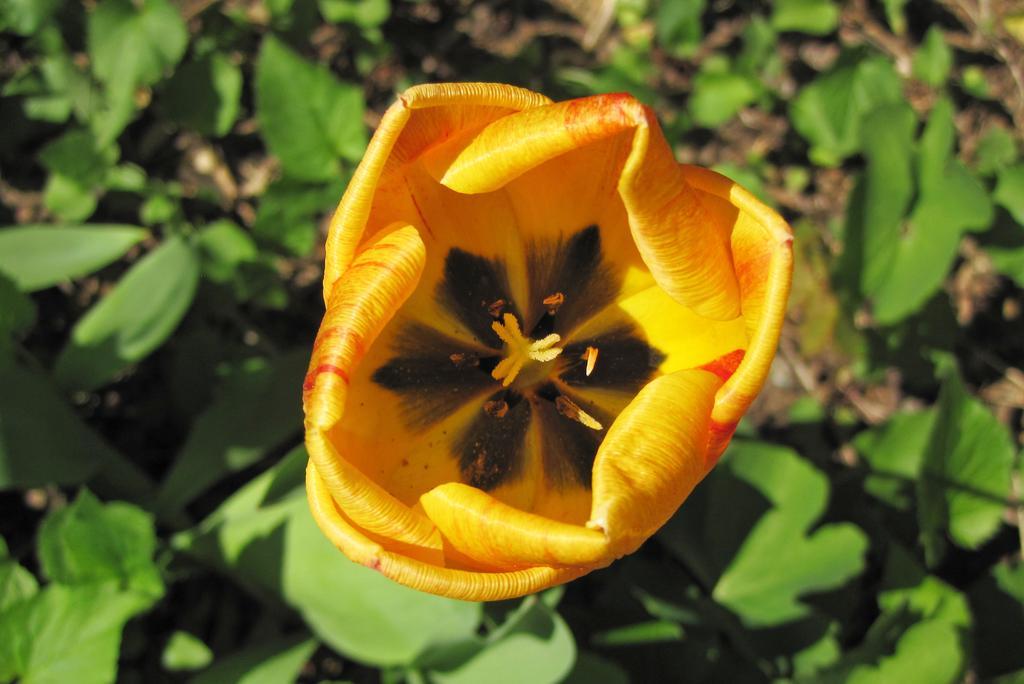Can you describe this image briefly? In this picture we can see a flower and leaves. 